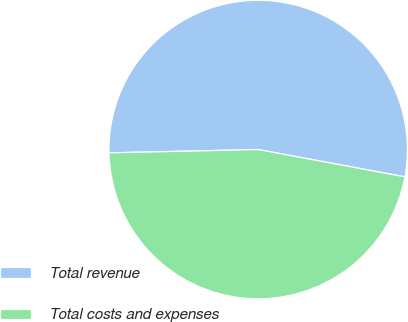Convert chart. <chart><loc_0><loc_0><loc_500><loc_500><pie_chart><fcel>Total revenue<fcel>Total costs and expenses<nl><fcel>53.28%<fcel>46.72%<nl></chart> 